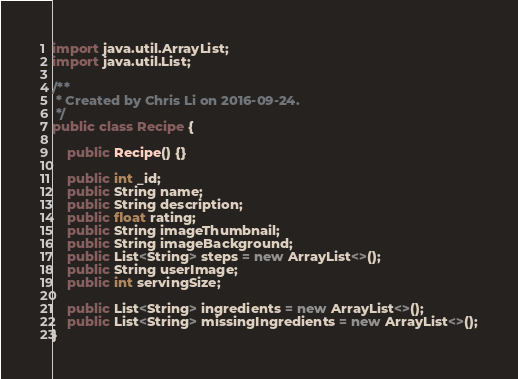<code> <loc_0><loc_0><loc_500><loc_500><_Java_>
import java.util.ArrayList;
import java.util.List;

/**
 * Created by Chris Li on 2016-09-24.
 */
public class Recipe {

    public Recipe() {}

    public int _id;
    public String name;
    public String description;
    public float rating;
    public String imageThumbnail;
    public String imageBackground;
    public List<String> steps = new ArrayList<>();
    public String userImage;
    public int servingSize;

    public List<String> ingredients = new ArrayList<>();
    public List<String> missingIngredients = new ArrayList<>();
}
</code> 